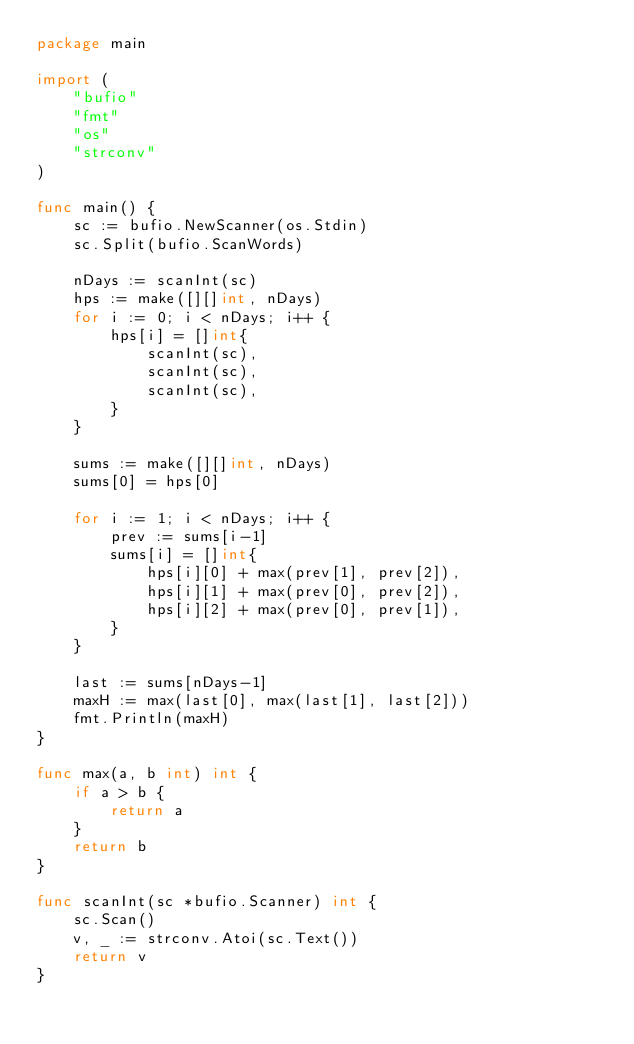Convert code to text. <code><loc_0><loc_0><loc_500><loc_500><_Go_>package main

import (
	"bufio"
	"fmt"
	"os"
	"strconv"
)

func main() {
	sc := bufio.NewScanner(os.Stdin)
	sc.Split(bufio.ScanWords)

	nDays := scanInt(sc)
	hps := make([][]int, nDays)
	for i := 0; i < nDays; i++ {
		hps[i] = []int{
			scanInt(sc),
			scanInt(sc),
			scanInt(sc),
		}
	}

	sums := make([][]int, nDays)
	sums[0] = hps[0]

	for i := 1; i < nDays; i++ {
		prev := sums[i-1]
		sums[i] = []int{
			hps[i][0] + max(prev[1], prev[2]),
			hps[i][1] + max(prev[0], prev[2]),
			hps[i][2] + max(prev[0], prev[1]),
		}
	}

	last := sums[nDays-1]
	maxH := max(last[0], max(last[1], last[2]))
	fmt.Println(maxH)
}

func max(a, b int) int {
	if a > b {
		return a
	}
	return b
}

func scanInt(sc *bufio.Scanner) int {
	sc.Scan()
	v, _ := strconv.Atoi(sc.Text())
	return v
}
</code> 